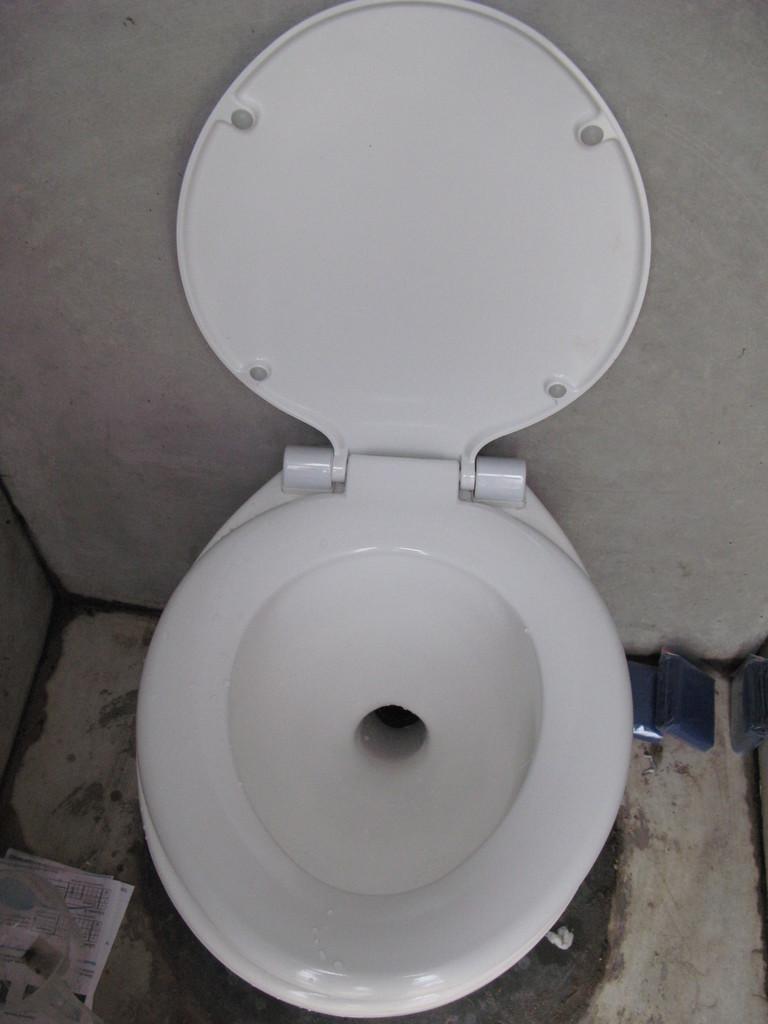Could you give a brief overview of what you see in this image? In this image we can see a toilet and a wall. On the bottom of the image we can see some papers on the floor. 